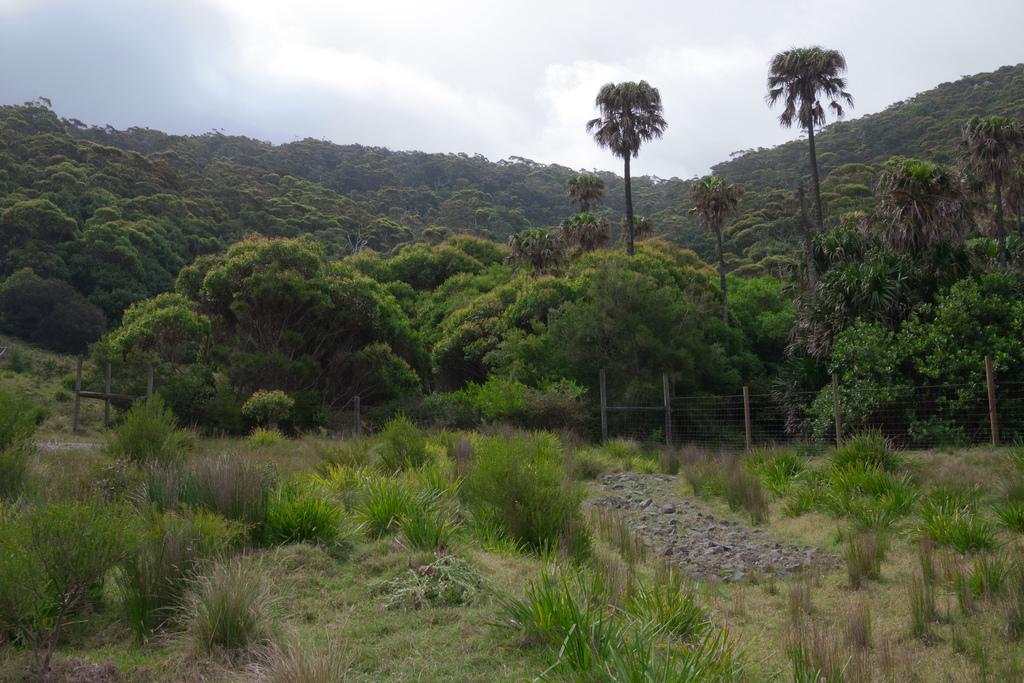What type of vegetation can be seen in the image? There are trees, grass, and plants in the image. What is the color of the trees in the image? The trees are green in color. What else is present in the image besides vegetation? There are stones in the image. What part of the natural environment is visible in the image? The sky is visible in the image. What type of account is being discussed in the image? There is no account being discussed in the image; it features trees, grass, plants, stones, and the sky. Can you see any space or planets in the image? No, there is no space or planets visible in the image; it is a natural scene with trees, grass, plants, stones, and the sky. 